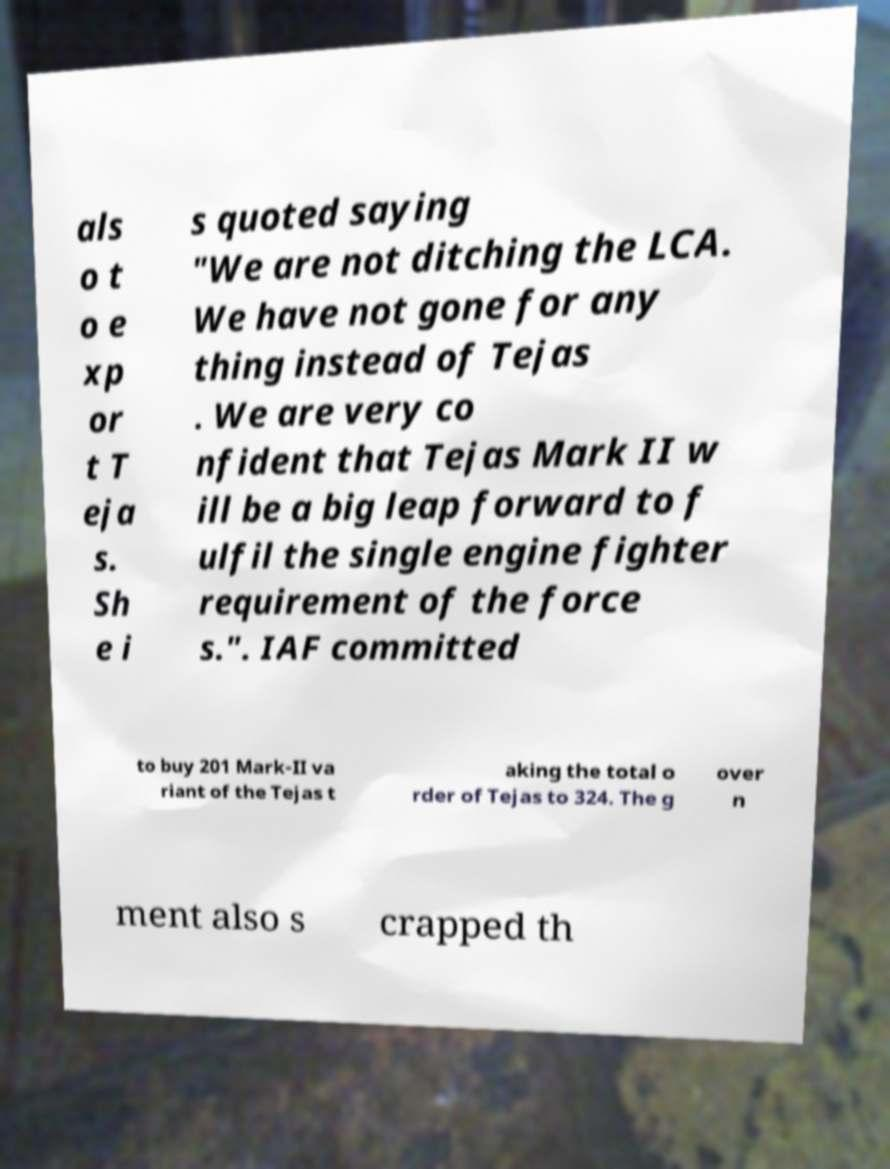Could you extract and type out the text from this image? als o t o e xp or t T eja s. Sh e i s quoted saying "We are not ditching the LCA. We have not gone for any thing instead of Tejas . We are very co nfident that Tejas Mark II w ill be a big leap forward to f ulfil the single engine fighter requirement of the force s.". IAF committed to buy 201 Mark-II va riant of the Tejas t aking the total o rder of Tejas to 324. The g over n ment also s crapped th 